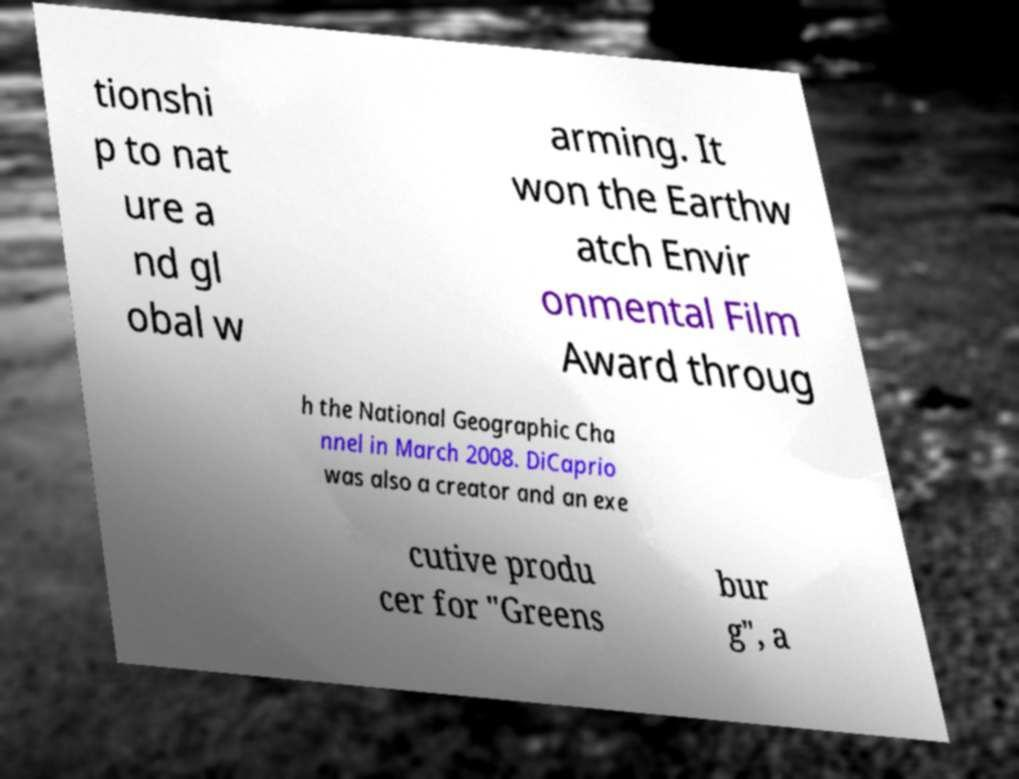Can you read and provide the text displayed in the image?This photo seems to have some interesting text. Can you extract and type it out for me? tionshi p to nat ure a nd gl obal w arming. It won the Earthw atch Envir onmental Film Award throug h the National Geographic Cha nnel in March 2008. DiCaprio was also a creator and an exe cutive produ cer for "Greens bur g", a 